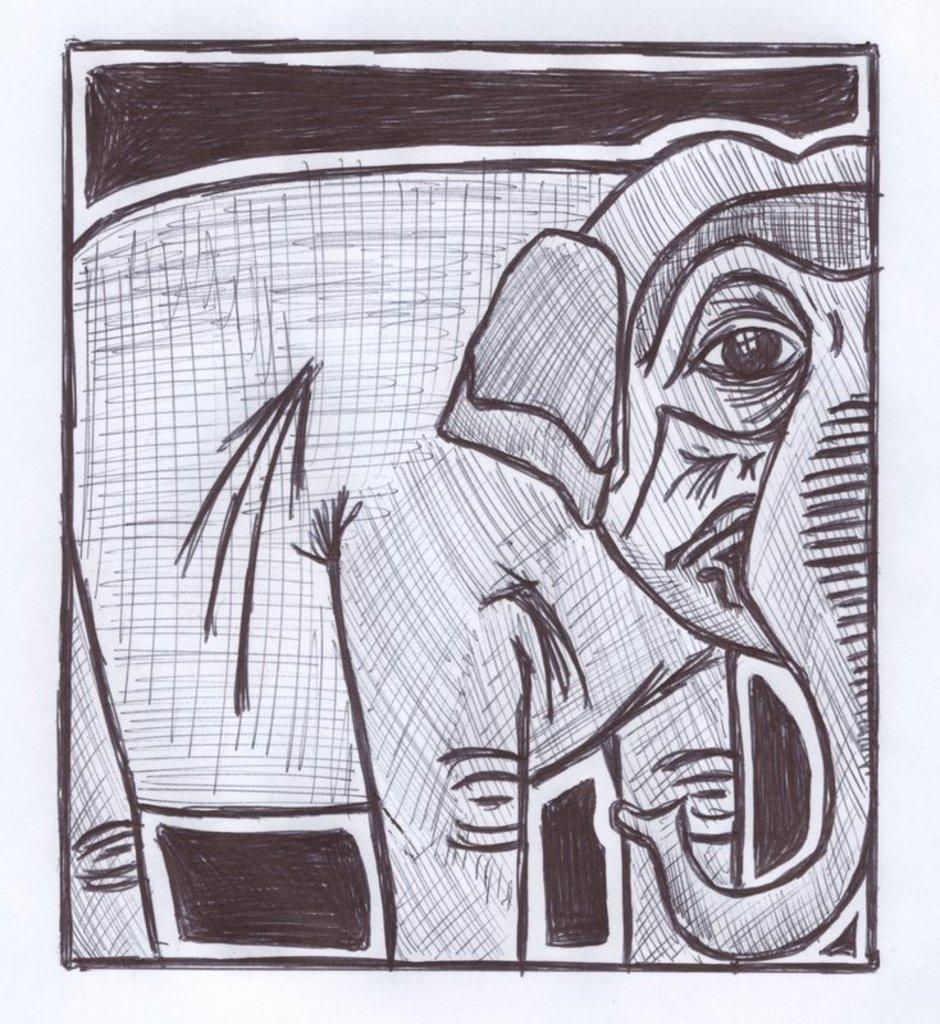How would you summarize this image in a sentence or two? In the picture I can see the drawing of an elephant. 